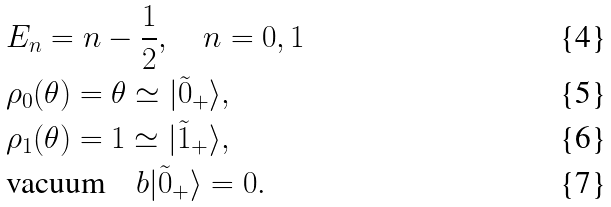<formula> <loc_0><loc_0><loc_500><loc_500>& E _ { n } = n - \frac { 1 } { 2 } , \quad n = 0 , 1 \\ & \rho _ { 0 } ( \theta ) = \theta \simeq | \tilde { 0 } _ { + } \rangle , \\ & \rho _ { 1 } ( \theta ) = 1 \simeq | \tilde { 1 } _ { + } \rangle , \\ & \text {vacuum} \quad b | \tilde { 0 } _ { + } \rangle = 0 .</formula> 